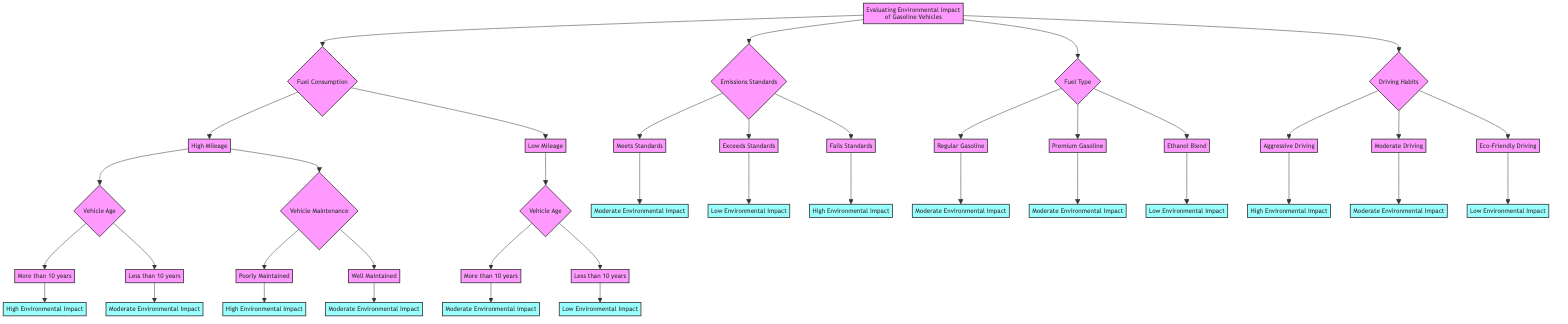What are the main criteria used to evaluate the environmental impact of gasoline vehicles? The diagram indicates four main criteria: Fuel Consumption, Emissions Standards, Fuel Type, and Driving Habits, each of which leads to outcomes regarding environmental impact.
Answer: Fuel Consumption, Emissions Standards, Fuel Type, Driving Habits How many outcomes are possible based on the Fuel Consumption branch? Under the Fuel Consumption branch, the options split into High Mileage and Low Mileage, which further branch out into different outcomes, leading to a total of four distinct outcomes.
Answer: Four What is the outcome if the vehicle has High Mileage and is more than 10 years old? Following the path for High Mileage, if we choose More than 10 years for Vehicle Age, this directly leads to the High Environmental Impact outcome.
Answer: High Environmental Impact If a vehicle exceeds emissions standards, what is the expected environmental impact? The Emissions Standards node states that if a vehicle Exceeds Standards, it leads to a Low Environmental Impact outcome.
Answer: Low Environmental Impact In the Driving Habits branch, which category results in the highest environmental impact? The Driving Habits branch presents three categories: Aggressive Driving, Moderate Driving, and Eco-Friendly Driving. Aggressive Driving has been specified to result in High Environmental Impact, which is the highest of the three.
Answer: Aggressive Driving What happens if a vehicle is poorly maintained and has high mileage? Choosing High Mileage leads to the Vehicle Maintenance node, where Poorly Maintained results in High Environmental Impact, signifying a significant negative effect on the environment.
Answer: High Environmental Impact Which type of fuel has the lowest environmental impact according to the diagram? Within the Fuel Type options, Ethanol Blend is listed, and this outcome is categorized as Low Environmental Impact, indicating it performs better environmentally compared to the others.
Answer: Ethanol Blend What is the environmental impact of a vehicle under Moderate Driving with a premium gasoline type? The Driving Habits branch shows that Moderate Driving results in Moderate Environmental Impact, while Premium Gasoline, located in the Fuel Type branch, also leads to Moderate Environmental Impact. Together, they maintain this moderate status as they don't directly combine for a different outcome.
Answer: Moderate Environmental Impact What is the environmental impact of a vehicle that fails emissions standards regardless of other factors? According to the Emissions Standards node, if a vehicle Fails Standards, it leads straight to the High Environmental Impact outcome, indicating a critical level of negative environmental effect.
Answer: High Environmental Impact 